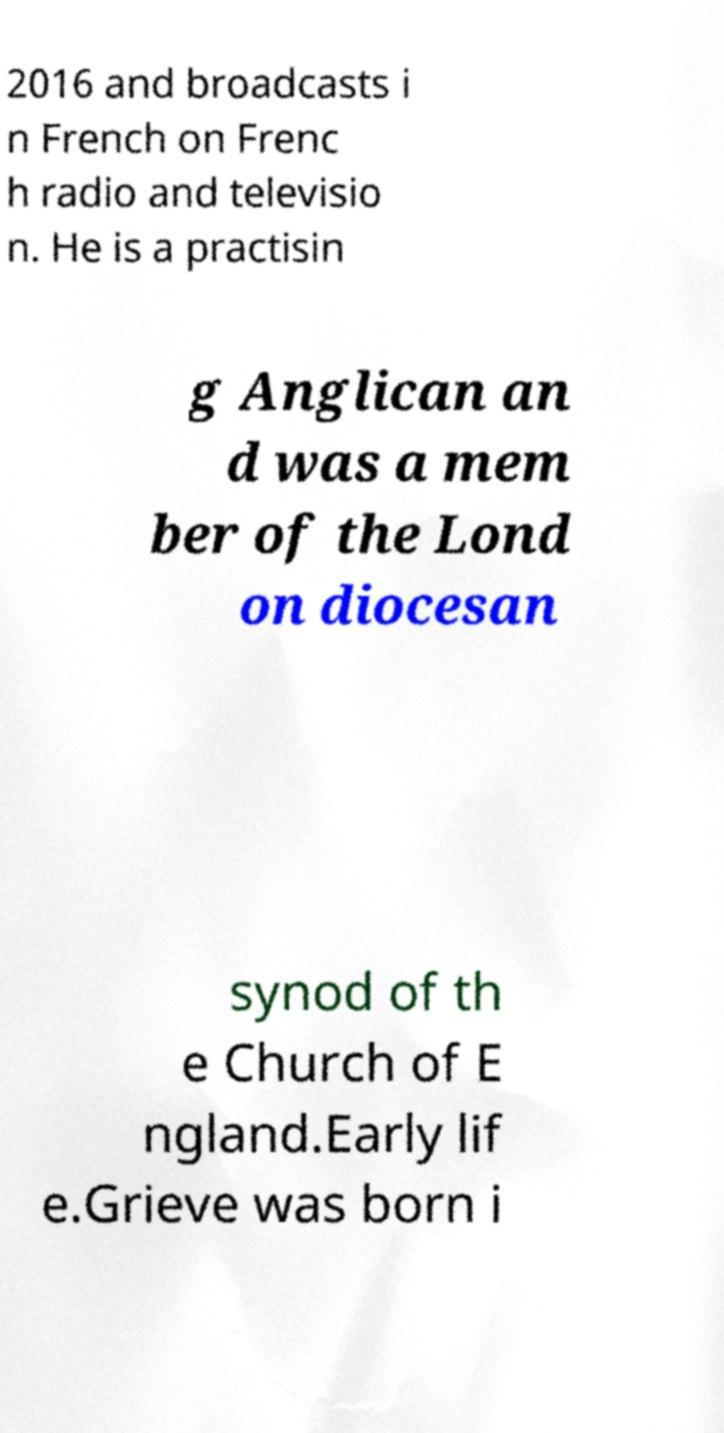There's text embedded in this image that I need extracted. Can you transcribe it verbatim? 2016 and broadcasts i n French on Frenc h radio and televisio n. He is a practisin g Anglican an d was a mem ber of the Lond on diocesan synod of th e Church of E ngland.Early lif e.Grieve was born i 